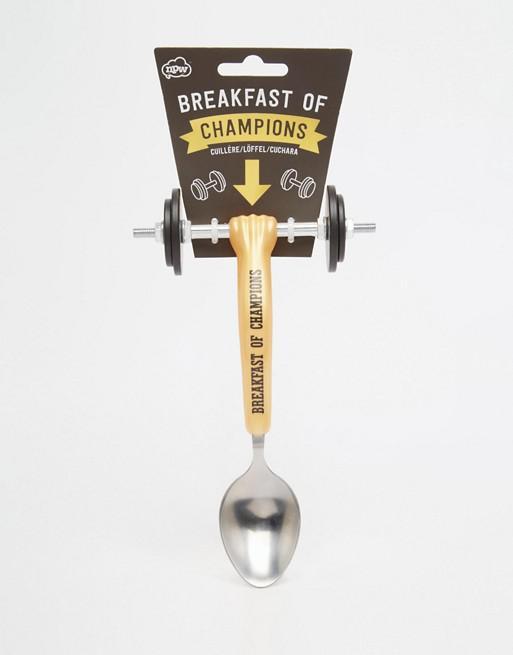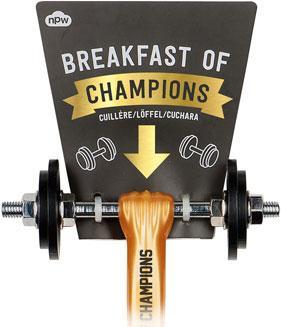The first image is the image on the left, the second image is the image on the right. Assess this claim about the two images: "In one image, a fancy spoon with wheels is held in a hand.". Correct or not? Answer yes or no. No. The first image is the image on the left, the second image is the image on the right. Examine the images to the left and right. Is the description "there is a hand in one of the images" accurate? Answer yes or no. No. 